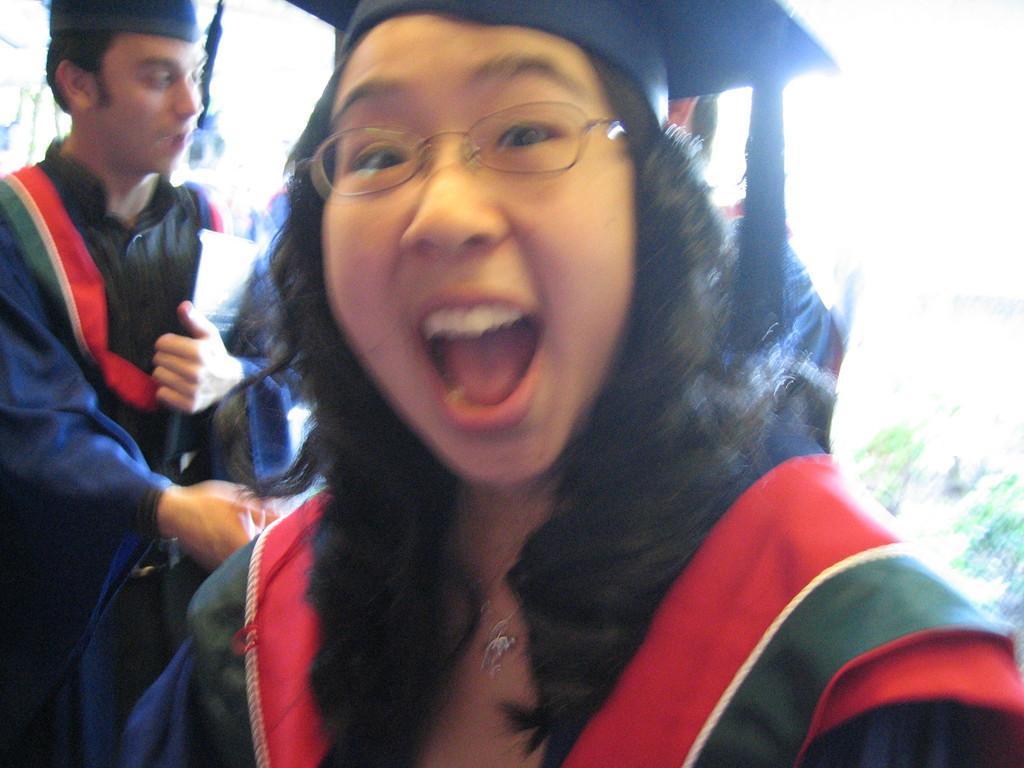In one or two sentences, can you explain what this image depicts? In this picture there is a girl wearing convocation dress smiling and giving a pose into the camera. Behind there is a boy wearing a black gown and holding the white papers in the hand. Behind there is a blur background. 